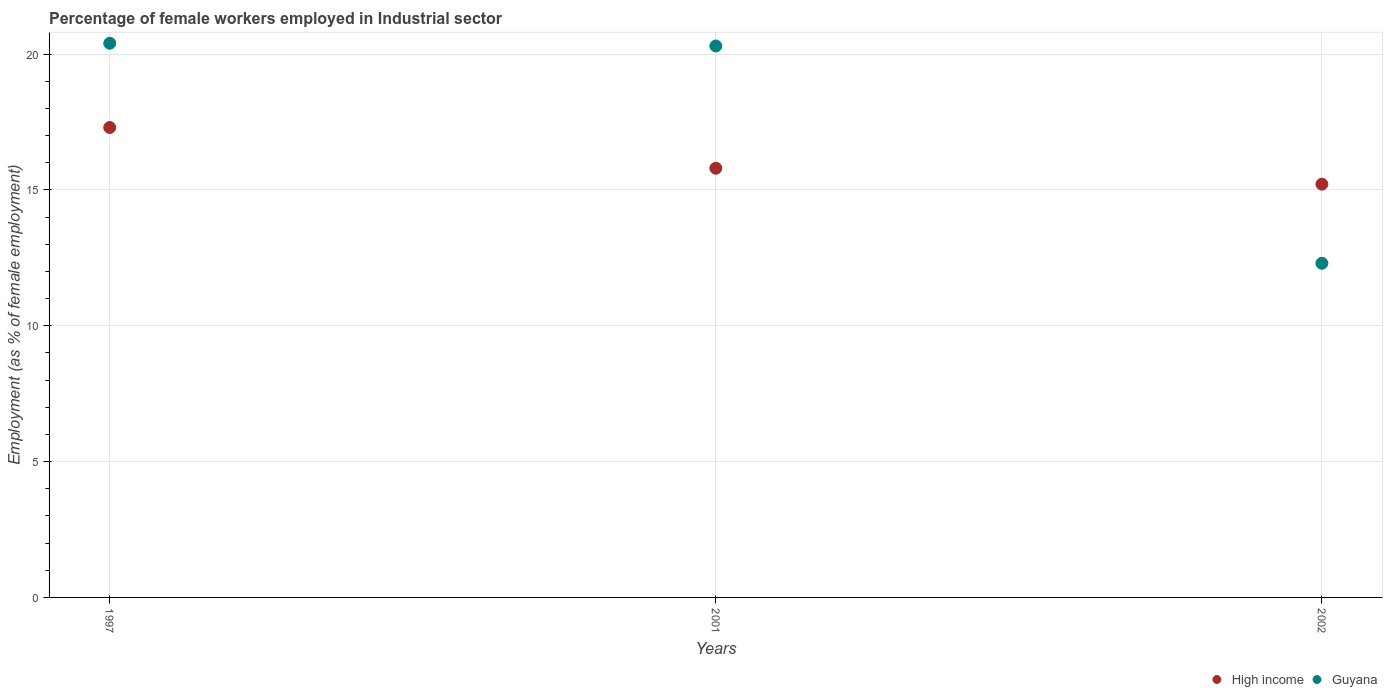How many different coloured dotlines are there?
Offer a terse response. 2. Is the number of dotlines equal to the number of legend labels?
Your answer should be very brief. Yes. What is the percentage of females employed in Industrial sector in High income in 1997?
Make the answer very short. 17.3. Across all years, what is the maximum percentage of females employed in Industrial sector in High income?
Offer a very short reply. 17.3. Across all years, what is the minimum percentage of females employed in Industrial sector in Guyana?
Ensure brevity in your answer.  12.3. In which year was the percentage of females employed in Industrial sector in Guyana maximum?
Keep it short and to the point. 1997. In which year was the percentage of females employed in Industrial sector in Guyana minimum?
Make the answer very short. 2002. What is the total percentage of females employed in Industrial sector in Guyana in the graph?
Your answer should be very brief. 53. What is the difference between the percentage of females employed in Industrial sector in Guyana in 2001 and that in 2002?
Give a very brief answer. 8. What is the difference between the percentage of females employed in Industrial sector in Guyana in 2002 and the percentage of females employed in Industrial sector in High income in 1997?
Offer a terse response. -5. What is the average percentage of females employed in Industrial sector in High income per year?
Keep it short and to the point. 16.1. In the year 2002, what is the difference between the percentage of females employed in Industrial sector in Guyana and percentage of females employed in Industrial sector in High income?
Offer a terse response. -2.91. What is the ratio of the percentage of females employed in Industrial sector in Guyana in 1997 to that in 2001?
Provide a succinct answer. 1. Is the percentage of females employed in Industrial sector in Guyana in 2001 less than that in 2002?
Your response must be concise. No. What is the difference between the highest and the second highest percentage of females employed in Industrial sector in High income?
Provide a succinct answer. 1.5. What is the difference between the highest and the lowest percentage of females employed in Industrial sector in High income?
Your answer should be very brief. 2.09. What is the difference between two consecutive major ticks on the Y-axis?
Give a very brief answer. 5. Does the graph contain grids?
Ensure brevity in your answer.  Yes. How many legend labels are there?
Your answer should be compact. 2. How are the legend labels stacked?
Your answer should be very brief. Horizontal. What is the title of the graph?
Offer a terse response. Percentage of female workers employed in Industrial sector. Does "Puerto Rico" appear as one of the legend labels in the graph?
Ensure brevity in your answer.  No. What is the label or title of the Y-axis?
Your answer should be very brief. Employment (as % of female employment). What is the Employment (as % of female employment) in High income in 1997?
Your answer should be compact. 17.3. What is the Employment (as % of female employment) of Guyana in 1997?
Your response must be concise. 20.4. What is the Employment (as % of female employment) of High income in 2001?
Make the answer very short. 15.8. What is the Employment (as % of female employment) in Guyana in 2001?
Your answer should be compact. 20.3. What is the Employment (as % of female employment) of High income in 2002?
Your answer should be very brief. 15.21. What is the Employment (as % of female employment) of Guyana in 2002?
Keep it short and to the point. 12.3. Across all years, what is the maximum Employment (as % of female employment) in High income?
Offer a terse response. 17.3. Across all years, what is the maximum Employment (as % of female employment) of Guyana?
Your response must be concise. 20.4. Across all years, what is the minimum Employment (as % of female employment) in High income?
Make the answer very short. 15.21. Across all years, what is the minimum Employment (as % of female employment) in Guyana?
Provide a succinct answer. 12.3. What is the total Employment (as % of female employment) in High income in the graph?
Provide a short and direct response. 48.31. What is the difference between the Employment (as % of female employment) in High income in 1997 and that in 2001?
Keep it short and to the point. 1.5. What is the difference between the Employment (as % of female employment) of High income in 1997 and that in 2002?
Provide a short and direct response. 2.09. What is the difference between the Employment (as % of female employment) of Guyana in 1997 and that in 2002?
Ensure brevity in your answer.  8.1. What is the difference between the Employment (as % of female employment) of High income in 2001 and that in 2002?
Keep it short and to the point. 0.59. What is the difference between the Employment (as % of female employment) in Guyana in 2001 and that in 2002?
Your answer should be compact. 8. What is the difference between the Employment (as % of female employment) in High income in 1997 and the Employment (as % of female employment) in Guyana in 2001?
Your answer should be compact. -3. What is the difference between the Employment (as % of female employment) of High income in 1997 and the Employment (as % of female employment) of Guyana in 2002?
Ensure brevity in your answer.  5. What is the difference between the Employment (as % of female employment) of High income in 2001 and the Employment (as % of female employment) of Guyana in 2002?
Ensure brevity in your answer.  3.5. What is the average Employment (as % of female employment) of High income per year?
Keep it short and to the point. 16.1. What is the average Employment (as % of female employment) in Guyana per year?
Give a very brief answer. 17.67. In the year 1997, what is the difference between the Employment (as % of female employment) of High income and Employment (as % of female employment) of Guyana?
Give a very brief answer. -3.1. In the year 2001, what is the difference between the Employment (as % of female employment) of High income and Employment (as % of female employment) of Guyana?
Keep it short and to the point. -4.5. In the year 2002, what is the difference between the Employment (as % of female employment) in High income and Employment (as % of female employment) in Guyana?
Offer a very short reply. 2.91. What is the ratio of the Employment (as % of female employment) in High income in 1997 to that in 2001?
Offer a very short reply. 1.09. What is the ratio of the Employment (as % of female employment) in Guyana in 1997 to that in 2001?
Provide a short and direct response. 1. What is the ratio of the Employment (as % of female employment) of High income in 1997 to that in 2002?
Your answer should be compact. 1.14. What is the ratio of the Employment (as % of female employment) of Guyana in 1997 to that in 2002?
Make the answer very short. 1.66. What is the ratio of the Employment (as % of female employment) in High income in 2001 to that in 2002?
Provide a short and direct response. 1.04. What is the ratio of the Employment (as % of female employment) in Guyana in 2001 to that in 2002?
Provide a short and direct response. 1.65. What is the difference between the highest and the second highest Employment (as % of female employment) of High income?
Ensure brevity in your answer.  1.5. What is the difference between the highest and the second highest Employment (as % of female employment) in Guyana?
Ensure brevity in your answer.  0.1. What is the difference between the highest and the lowest Employment (as % of female employment) in High income?
Offer a terse response. 2.09. 